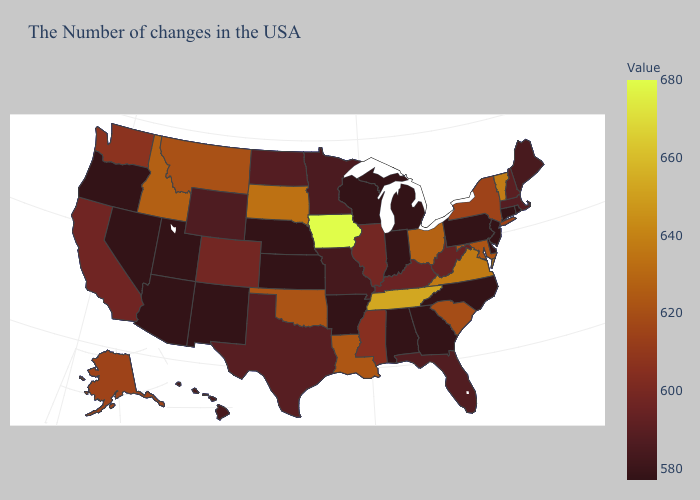Which states have the lowest value in the USA?
Short answer required. Rhode Island, Connecticut, New Jersey, Delaware, Pennsylvania, North Carolina, Georgia, Michigan, Indiana, Alabama, Wisconsin, Arkansas, Kansas, Nebraska, New Mexico, Utah, Arizona, Nevada, Oregon. Does Montana have the highest value in the USA?
Quick response, please. No. Which states have the lowest value in the USA?
Give a very brief answer. Rhode Island, Connecticut, New Jersey, Delaware, Pennsylvania, North Carolina, Georgia, Michigan, Indiana, Alabama, Wisconsin, Arkansas, Kansas, Nebraska, New Mexico, Utah, Arizona, Nevada, Oregon. Does Wisconsin have the lowest value in the USA?
Answer briefly. Yes. Does Nevada have the highest value in the West?
Write a very short answer. No. Does Arkansas have the highest value in the South?
Be succinct. No. Does Texas have the lowest value in the South?
Give a very brief answer. No. 